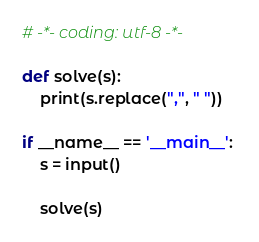Convert code to text. <code><loc_0><loc_0><loc_500><loc_500><_Python_># -*- coding: utf-8 -*-

def solve(s):
    print(s.replace(",", " "))

if __name__ == '__main__': 
    s = input()
    
    solve(s)</code> 